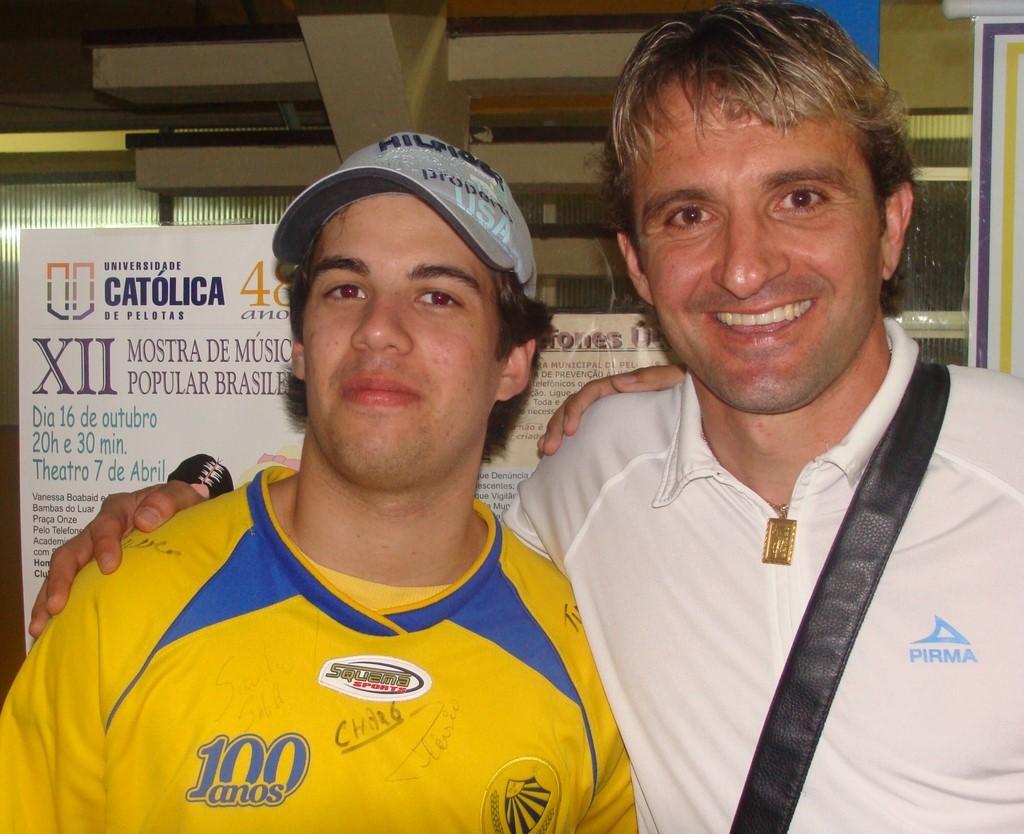What is the brand of the white shirt?
Provide a short and direct response. Pirma. What university are they at?
Offer a very short reply. Catolica. 